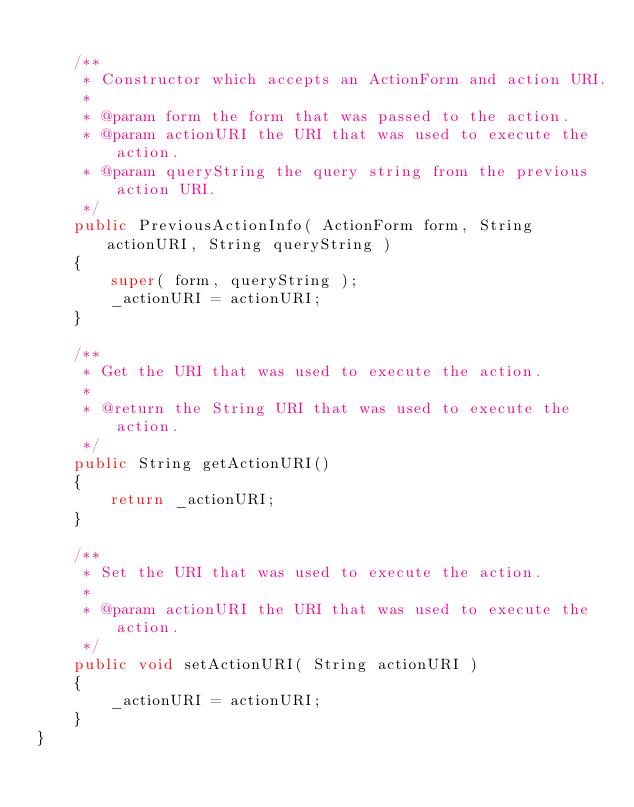<code> <loc_0><loc_0><loc_500><loc_500><_Java_>    
    /**
     * Constructor which accepts an ActionForm and action URI.
     * 
     * @param form the form that was passed to the action.
     * @param actionURI the URI that was used to execute the action.
     * @param queryString the query string from the previous action URI.
     */ 
    public PreviousActionInfo( ActionForm form, String actionURI, String queryString )
    {
        super( form, queryString );
        _actionURI = actionURI;
    }

    /**
     * Get the URI that was used to execute the action.
     * 
     * @return the String URI that was used to execute the action.
     */ 
    public String getActionURI()
    {
        return _actionURI;
    }

    /**
     * Set the URI that was used to execute the action.
     * 
     * @param actionURI the URI that was used to execute the action.
     */ 
    public void setActionURI( String actionURI )
    {
        _actionURI = actionURI;
    }
}
</code> 